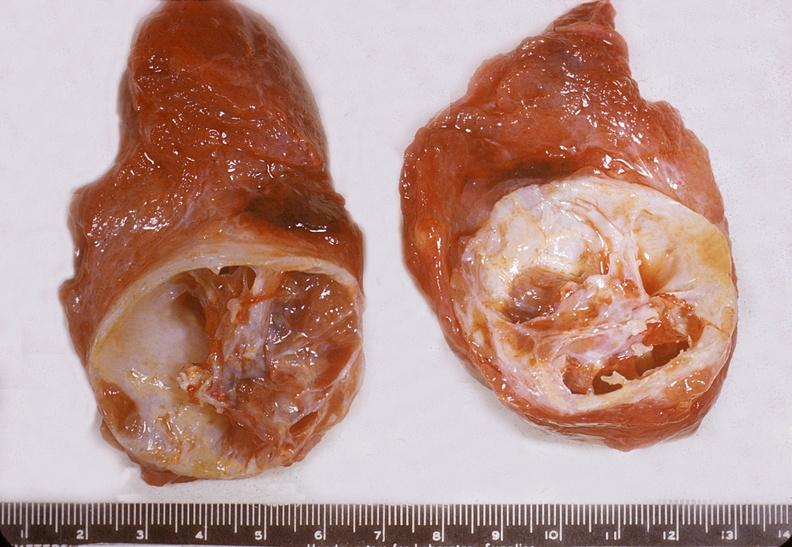where does this belong to?
Answer the question using a single word or phrase. Endocrine system 